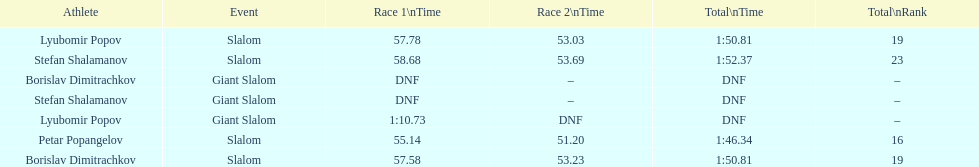Which sportsperson recorded a race timing beyond 1:00? Lyubomir Popov. Can you give me this table as a dict? {'header': ['Athlete', 'Event', 'Race 1\\nTime', 'Race 2\\nTime', 'Total\\nTime', 'Total\\nRank'], 'rows': [['Lyubomir Popov', 'Slalom', '57.78', '53.03', '1:50.81', '19'], ['Stefan Shalamanov', 'Slalom', '58.68', '53.69', '1:52.37', '23'], ['Borislav Dimitrachkov', 'Giant Slalom', 'DNF', '–', 'DNF', '–'], ['Stefan Shalamanov', 'Giant Slalom', 'DNF', '–', 'DNF', '–'], ['Lyubomir Popov', 'Giant Slalom', '1:10.73', 'DNF', 'DNF', '–'], ['Petar Popangelov', 'Slalom', '55.14', '51.20', '1:46.34', '16'], ['Borislav Dimitrachkov', 'Slalom', '57.58', '53.23', '1:50.81', '19']]} 